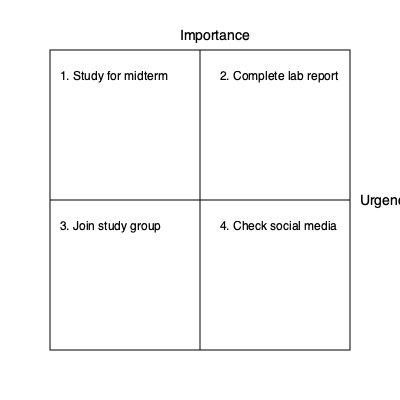Based on the Eisenhower Matrix shown above, which task should a computer engineering freshman prioritize first to maximize their academic success? To determine the priority of tasks using the Eisenhower Matrix, we need to consider both the importance and urgency of each task:

1. Analyze the matrix:
   - The x-axis represents urgency, increasing from left to right.
   - The y-axis represents importance, increasing from bottom to top.

2. Identify the quadrants:
   - Top-left: Important and not urgent
   - Top-right: Important and urgent
   - Bottom-left: Not important and not urgent
   - Bottom-right: Not important but urgent

3. Evaluate each task:
   - "Study for midterm" is in the top-left quadrant (important, not urgent)
   - "Complete lab report" is in the top-right quadrant (important and urgent)
   - "Join study group" is in the bottom-left quadrant (not important, not urgent)
   - "Check social media" is in the bottom-right quadrant (not important, but urgent)

4. Prioritize based on the matrix:
   - Tasks in the top-right quadrant (important and urgent) should be done first
   - Then, tasks in the top-left quadrant (important, not urgent)
   - Followed by tasks in the bottom-right quadrant (not important, but urgent)
   - Lastly, tasks in the bottom-left quadrant (not important, not urgent)

5. Conclusion:
   The task "Complete lab report" is in the top-right quadrant, making it both important and urgent. This should be prioritized first for maximum academic success.
Answer: Complete lab report 